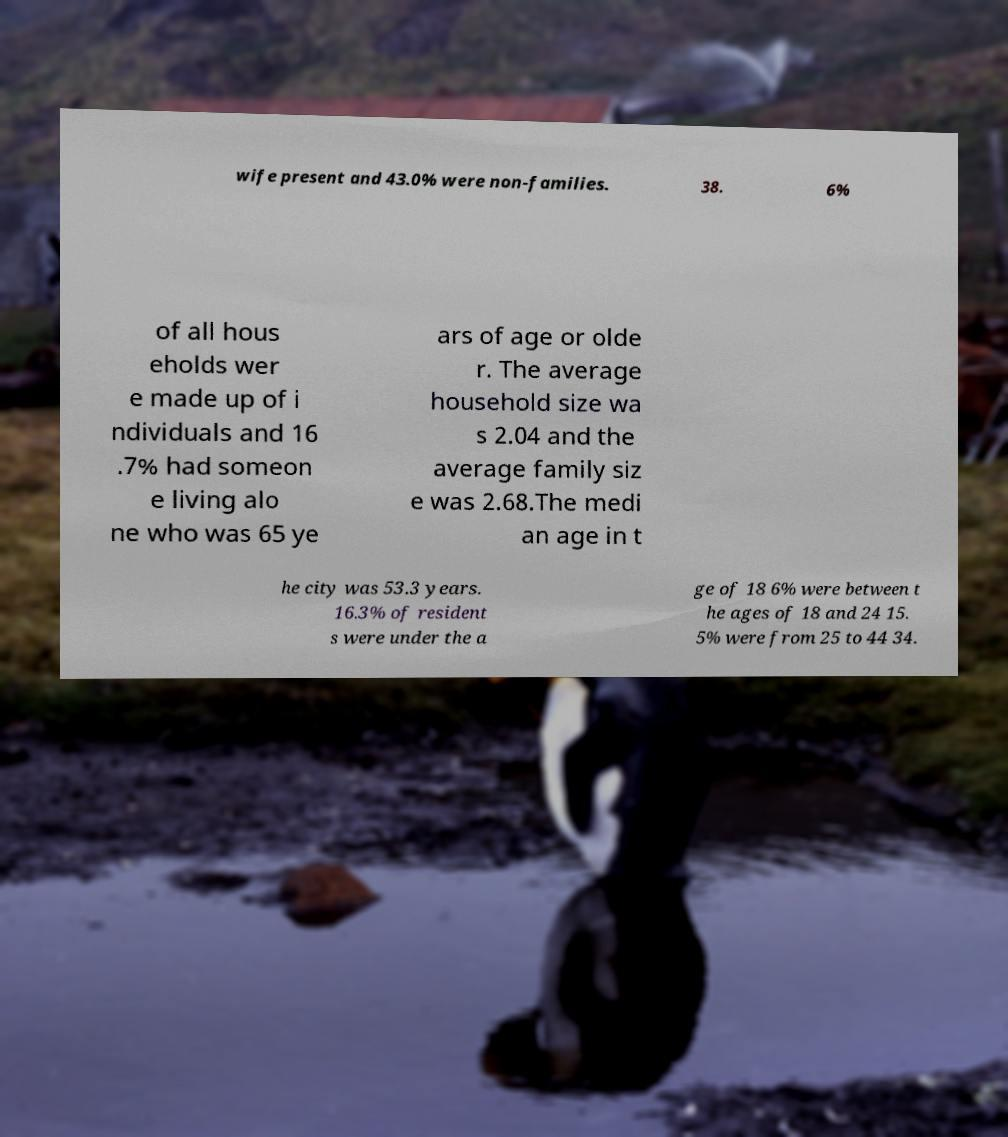There's text embedded in this image that I need extracted. Can you transcribe it verbatim? wife present and 43.0% were non-families. 38. 6% of all hous eholds wer e made up of i ndividuals and 16 .7% had someon e living alo ne who was 65 ye ars of age or olde r. The average household size wa s 2.04 and the average family siz e was 2.68.The medi an age in t he city was 53.3 years. 16.3% of resident s were under the a ge of 18 6% were between t he ages of 18 and 24 15. 5% were from 25 to 44 34. 